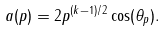<formula> <loc_0><loc_0><loc_500><loc_500>a ( p ) = 2 p ^ { ( k - 1 ) / 2 } \cos ( \theta _ { p } ) .</formula> 